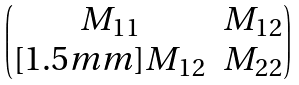<formula> <loc_0><loc_0><loc_500><loc_500>\begin{pmatrix} M _ { 1 1 } & M _ { 1 2 } \\ [ 1 . 5 m m ] M _ { 1 2 } & M _ { 2 2 } \end{pmatrix}</formula> 